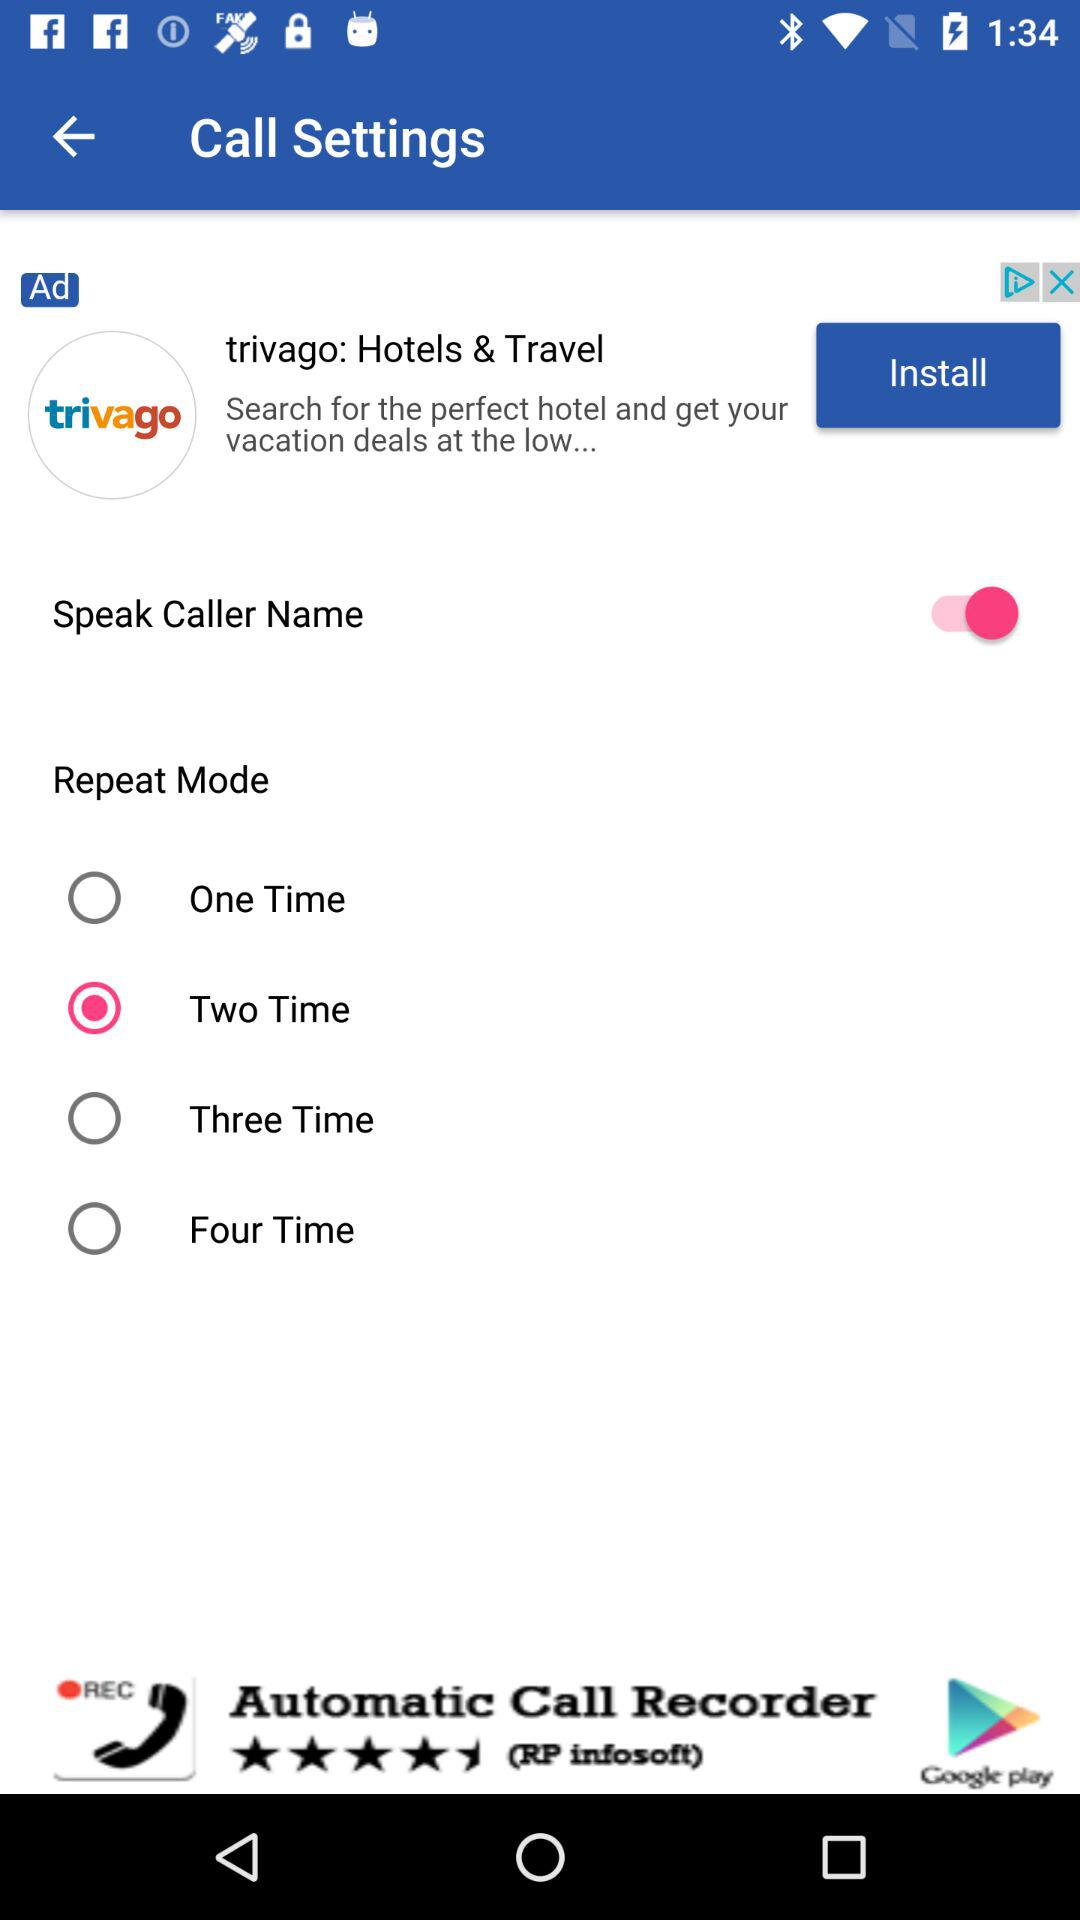What is the status of Speak Caller Name? The status of Speak Caller Name is on. 